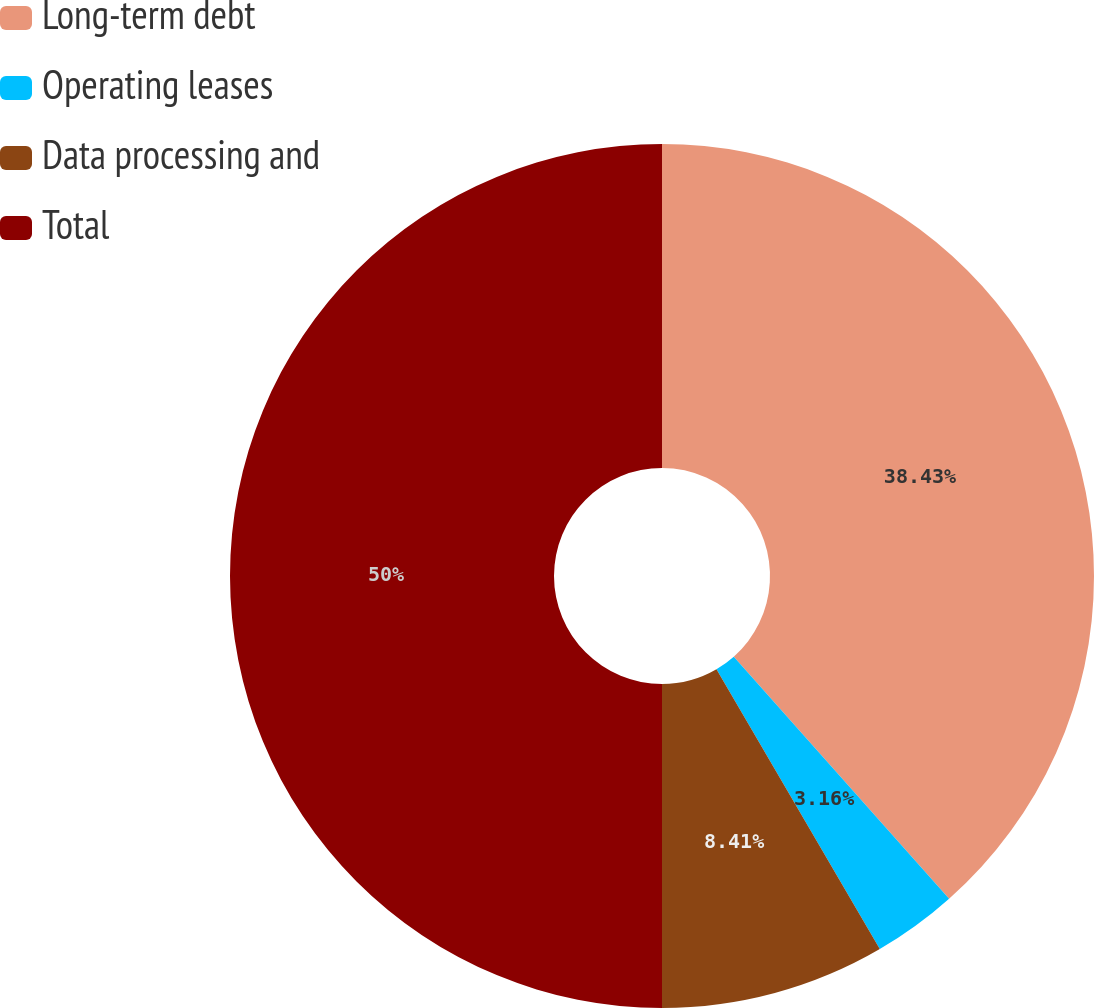Convert chart. <chart><loc_0><loc_0><loc_500><loc_500><pie_chart><fcel>Long-term debt<fcel>Operating leases<fcel>Data processing and<fcel>Total<nl><fcel>38.43%<fcel>3.16%<fcel>8.41%<fcel>50.0%<nl></chart> 